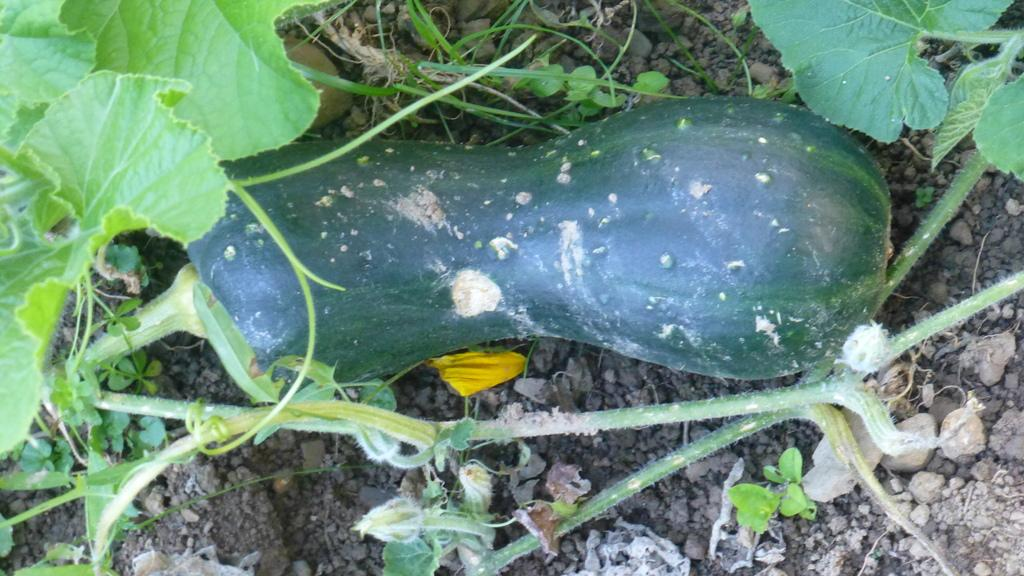What is the main subject in the center of the image? There is a vegetable in the center of the image. What else can be seen in the image besides the vegetable? There are plants and sand at the bottom of the image. Are there any other materials present at the bottom of the image? Yes, there are small stones at the bottom of the image. What type of voice can be heard coming from the vegetable in the image? There is no voice present in the image, as vegetables do not have the ability to produce sound. 